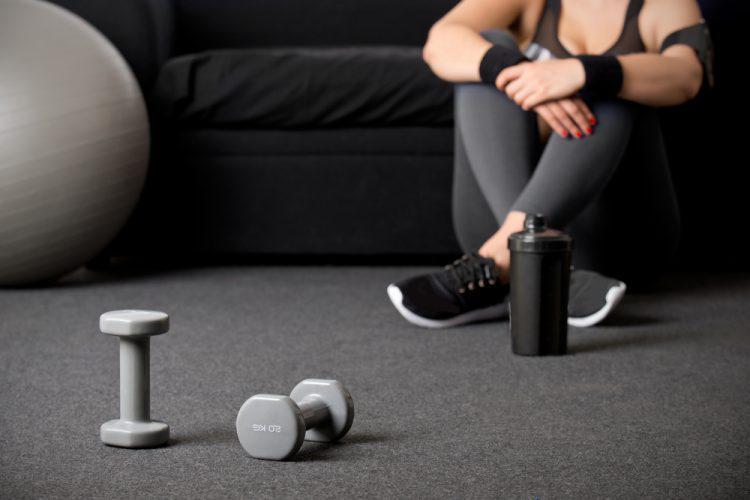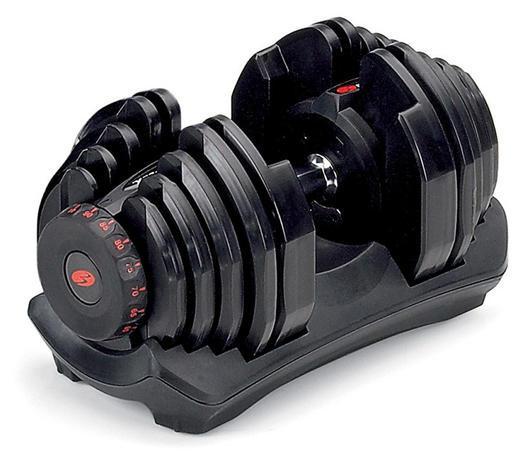The first image is the image on the left, the second image is the image on the right. Evaluate the accuracy of this statement regarding the images: "In the image on the left, at least 8 dumbbells are stored against a wall sitting in a straight line.". Is it true? Answer yes or no. No. 